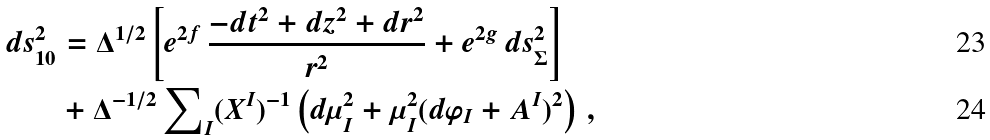<formula> <loc_0><loc_0><loc_500><loc_500>d s ^ { 2 } _ { 1 0 } & = \Delta ^ { 1 / 2 } \left [ e ^ { 2 f } \, \frac { - d t ^ { 2 } + d z ^ { 2 } + d r ^ { 2 } } { r ^ { 2 } } + e ^ { 2 g } \, d s ^ { 2 } _ { \Sigma } \right ] \\ & + \Delta ^ { - 1 / 2 } \sum \nolimits _ { I } ( X ^ { I } ) ^ { - 1 } \left ( d \mu _ { I } ^ { 2 } + \mu _ { I } ^ { 2 } ( d \varphi _ { I } + A ^ { I } ) ^ { 2 } \right ) \, ,</formula> 